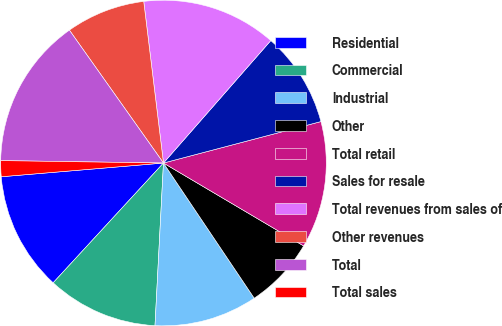Convert chart to OTSL. <chart><loc_0><loc_0><loc_500><loc_500><pie_chart><fcel>Residential<fcel>Commercial<fcel>Industrial<fcel>Other<fcel>Total retail<fcel>Sales for resale<fcel>Total revenues from sales of<fcel>Other revenues<fcel>Total<fcel>Total sales<nl><fcel>11.81%<fcel>11.02%<fcel>10.24%<fcel>7.09%<fcel>12.6%<fcel>9.45%<fcel>13.39%<fcel>7.87%<fcel>14.96%<fcel>1.58%<nl></chart> 